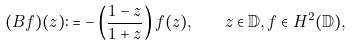Convert formula to latex. <formula><loc_0><loc_0><loc_500><loc_500>( B f ) ( z ) \colon = - \left ( \frac { 1 - z } { 1 + z } \right ) f ( z ) , \quad z \in \mathbb { D } , f \in H ^ { 2 } ( \mathbb { D } ) ,</formula> 